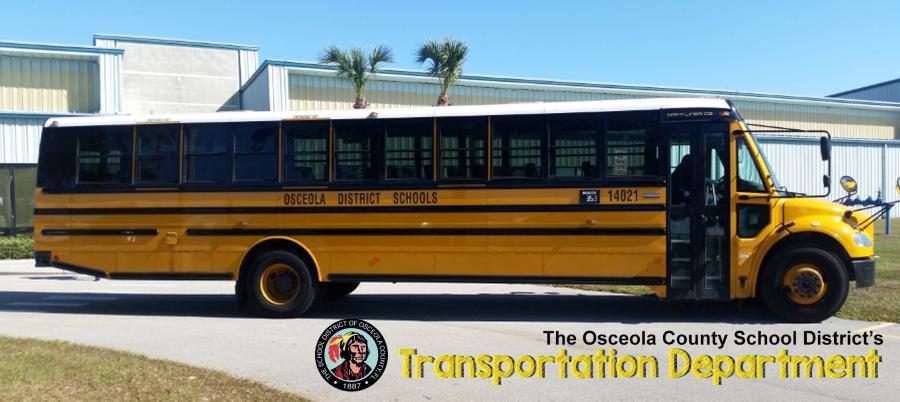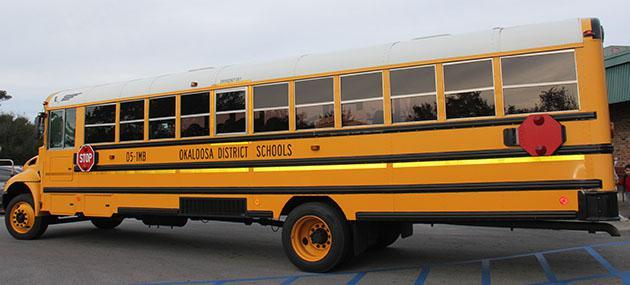The first image is the image on the left, the second image is the image on the right. Assess this claim about the two images: "At least one bus' doors are open.". Correct or not? Answer yes or no. No. The first image is the image on the left, the second image is the image on the right. Considering the images on both sides, is "The two school buses are facing nearly opposite directions." valid? Answer yes or no. Yes. 